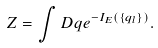<formula> <loc_0><loc_0><loc_500><loc_500>Z = \int D q e ^ { - I _ { E } ( \{ q _ { l } \} ) } .</formula> 